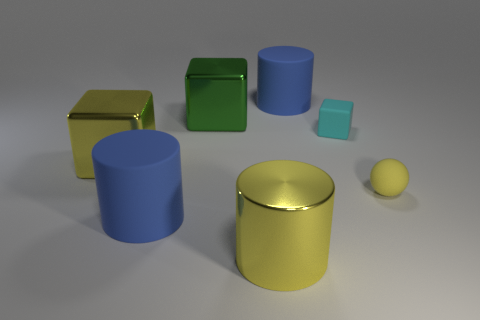What shape is the large thing that is the same color as the metal cylinder?
Provide a succinct answer. Cube. What is the color of the metal cylinder?
Your response must be concise. Yellow. Is the shape of the large object right of the large yellow shiny cylinder the same as  the big green metal thing?
Keep it short and to the point. No. How many objects are yellow objects that are in front of the matte ball or cyan blocks?
Offer a terse response. 2. Is there another green metallic object that has the same shape as the green thing?
Your response must be concise. No. What is the shape of the cyan rubber object that is the same size as the ball?
Make the answer very short. Cube. There is a big blue object left of the shiny cube to the right of the blue matte cylinder in front of the green shiny object; what shape is it?
Offer a very short reply. Cylinder. Does the green thing have the same shape as the rubber thing in front of the yellow sphere?
Offer a terse response. No. How many big objects are yellow matte things or green metallic cylinders?
Ensure brevity in your answer.  0. Is there another rubber block that has the same size as the green block?
Ensure brevity in your answer.  No. 